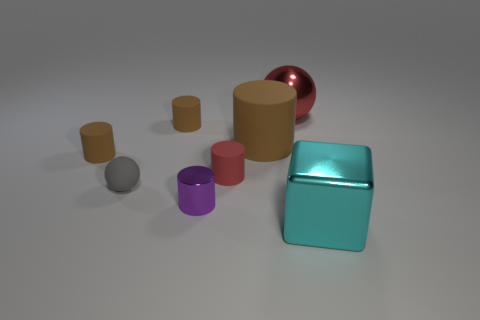Is there anything else that has the same shape as the big cyan object?
Make the answer very short. No. How big is the thing on the right side of the large shiny thing that is on the left side of the cyan metallic object?
Provide a succinct answer. Large. What number of metal balls have the same size as the cyan cube?
Provide a short and direct response. 1. Do the big metallic object behind the big cyan metal thing and the small rubber cylinder that is to the right of the purple metallic thing have the same color?
Make the answer very short. Yes. Are there any small purple shiny things in front of the gray sphere?
Your response must be concise. Yes. What color is the shiny object that is both behind the large cyan object and in front of the big red metallic sphere?
Keep it short and to the point. Purple. Is there another cylinder that has the same color as the big cylinder?
Your answer should be compact. Yes. Do the tiny thing right of the small purple shiny thing and the brown cylinder right of the purple metal cylinder have the same material?
Keep it short and to the point. Yes. There is a ball that is on the right side of the gray rubber thing; what is its size?
Provide a short and direct response. Large. How big is the gray ball?
Your answer should be compact. Small. 